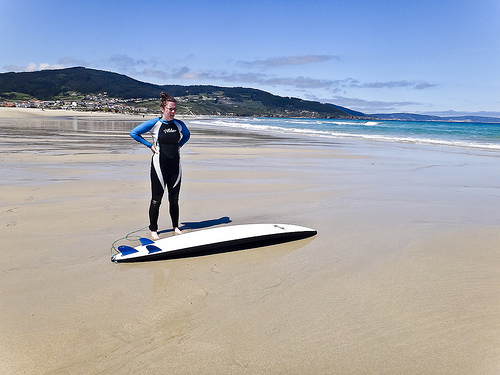Describe the atmosphere of the beach observed in the image. The beach exudes a tranquil yet invigorating vibe, with wide-open sandy stretches that invite relaxation and water sports alike. The clear blue skies and gentle waves enhance the serene ambiance. What are some activities you might find people engaging in at this location? Visitors can delight in various activities such as surfing, sunbathing, casual beach walks, beach volleyball, and possibly exploring nearby nature trails. 